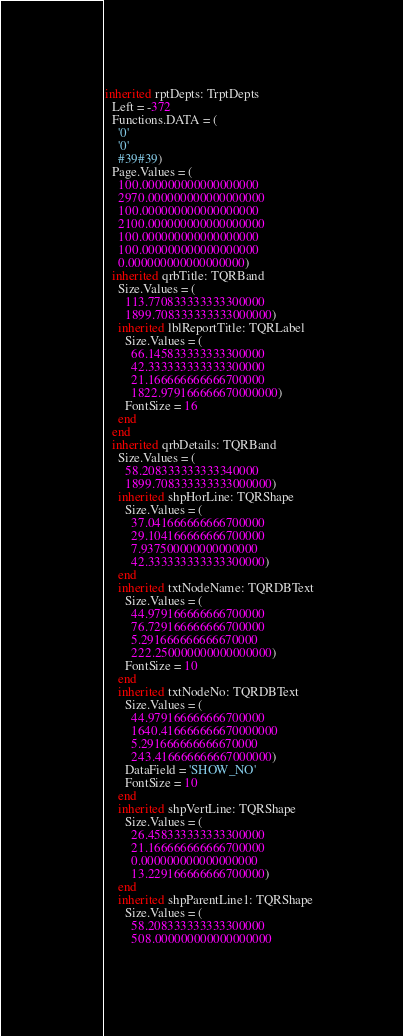Convert code to text. <code><loc_0><loc_0><loc_500><loc_500><_Pascal_>inherited rptDepts: TrptDepts
  Left = -372
  Functions.DATA = (
    '0'
    '0'
    #39#39)
  Page.Values = (
    100.000000000000000000
    2970.000000000000000000
    100.000000000000000000
    2100.000000000000000000
    100.000000000000000000
    100.000000000000000000
    0.000000000000000000)
  inherited qrbTitle: TQRBand
    Size.Values = (
      113.770833333333300000
      1899.708333333333000000)
    inherited lblReportTitle: TQRLabel
      Size.Values = (
        66.145833333333300000
        42.333333333333300000
        21.166666666666700000
        1822.979166666670000000)
      FontSize = 16
    end
  end
  inherited qrbDetails: TQRBand
    Size.Values = (
      58.208333333333340000
      1899.708333333333000000)
    inherited shpHorLine: TQRShape
      Size.Values = (
        37.041666666666700000
        29.104166666666700000
        7.937500000000000000
        42.333333333333300000)
    end
    inherited txtNodeName: TQRDBText
      Size.Values = (
        44.979166666666700000
        76.729166666666700000
        5.291666666666670000
        222.250000000000000000)
      FontSize = 10
    end
    inherited txtNodeNo: TQRDBText
      Size.Values = (
        44.979166666666700000
        1640.416666666670000000
        5.291666666666670000
        243.416666666667000000)
      DataField = 'SHOW_NO'
      FontSize = 10
    end
    inherited shpVertLine: TQRShape
      Size.Values = (
        26.458333333333300000
        21.166666666666700000
        0.000000000000000000
        13.229166666666700000)
    end
    inherited shpParentLine1: TQRShape
      Size.Values = (
        58.208333333333300000
        508.000000000000000000</code> 